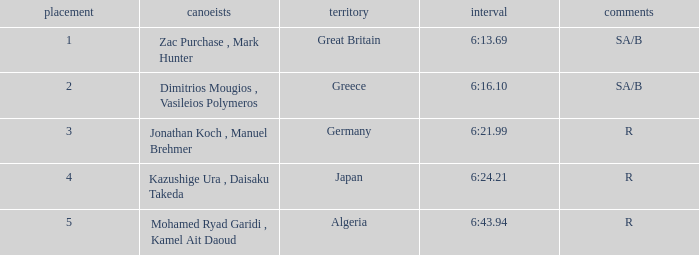What are the notes with the time 6:24.21? R. 